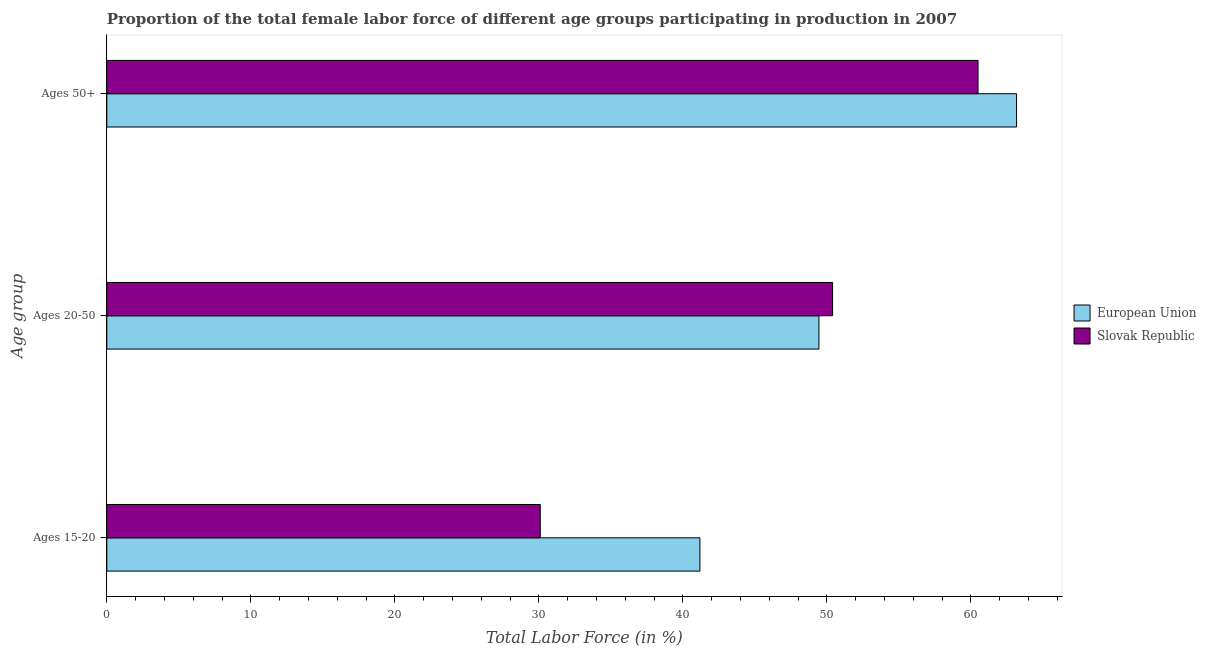Are the number of bars on each tick of the Y-axis equal?
Give a very brief answer. Yes. How many bars are there on the 2nd tick from the top?
Offer a very short reply. 2. What is the label of the 1st group of bars from the top?
Offer a terse response. Ages 50+. What is the percentage of female labor force above age 50 in Slovak Republic?
Keep it short and to the point. 60.5. Across all countries, what is the maximum percentage of female labor force within the age group 20-50?
Give a very brief answer. 50.4. Across all countries, what is the minimum percentage of female labor force above age 50?
Offer a terse response. 60.5. In which country was the percentage of female labor force within the age group 20-50 maximum?
Provide a succinct answer. Slovak Republic. In which country was the percentage of female labor force within the age group 15-20 minimum?
Keep it short and to the point. Slovak Republic. What is the total percentage of female labor force above age 50 in the graph?
Give a very brief answer. 123.67. What is the difference between the percentage of female labor force above age 50 in Slovak Republic and that in European Union?
Provide a short and direct response. -2.67. What is the difference between the percentage of female labor force within the age group 15-20 in European Union and the percentage of female labor force within the age group 20-50 in Slovak Republic?
Offer a terse response. -9.21. What is the average percentage of female labor force above age 50 per country?
Make the answer very short. 61.84. What is the difference between the percentage of female labor force above age 50 and percentage of female labor force within the age group 15-20 in European Union?
Provide a succinct answer. 21.99. What is the ratio of the percentage of female labor force above age 50 in European Union to that in Slovak Republic?
Make the answer very short. 1.04. Is the percentage of female labor force within the age group 15-20 in Slovak Republic less than that in European Union?
Your answer should be compact. Yes. Is the difference between the percentage of female labor force within the age group 20-50 in Slovak Republic and European Union greater than the difference between the percentage of female labor force above age 50 in Slovak Republic and European Union?
Ensure brevity in your answer.  Yes. What is the difference between the highest and the second highest percentage of female labor force within the age group 20-50?
Provide a succinct answer. 0.95. What is the difference between the highest and the lowest percentage of female labor force within the age group 15-20?
Your answer should be compact. 11.09. Is the sum of the percentage of female labor force within the age group 15-20 in Slovak Republic and European Union greater than the maximum percentage of female labor force above age 50 across all countries?
Give a very brief answer. Yes. Is it the case that in every country, the sum of the percentage of female labor force within the age group 15-20 and percentage of female labor force within the age group 20-50 is greater than the percentage of female labor force above age 50?
Keep it short and to the point. Yes. How many bars are there?
Your response must be concise. 6. Are all the bars in the graph horizontal?
Your answer should be very brief. Yes. How many countries are there in the graph?
Your answer should be compact. 2. What is the difference between two consecutive major ticks on the X-axis?
Your answer should be very brief. 10. Does the graph contain any zero values?
Give a very brief answer. No. Where does the legend appear in the graph?
Keep it short and to the point. Center right. How many legend labels are there?
Your response must be concise. 2. What is the title of the graph?
Make the answer very short. Proportion of the total female labor force of different age groups participating in production in 2007. Does "Arab World" appear as one of the legend labels in the graph?
Provide a succinct answer. No. What is the label or title of the X-axis?
Offer a very short reply. Total Labor Force (in %). What is the label or title of the Y-axis?
Offer a terse response. Age group. What is the Total Labor Force (in %) of European Union in Ages 15-20?
Your answer should be very brief. 41.19. What is the Total Labor Force (in %) of Slovak Republic in Ages 15-20?
Offer a terse response. 30.1. What is the Total Labor Force (in %) in European Union in Ages 20-50?
Your response must be concise. 49.45. What is the Total Labor Force (in %) of Slovak Republic in Ages 20-50?
Your answer should be very brief. 50.4. What is the Total Labor Force (in %) in European Union in Ages 50+?
Provide a succinct answer. 63.17. What is the Total Labor Force (in %) in Slovak Republic in Ages 50+?
Your answer should be very brief. 60.5. Across all Age group, what is the maximum Total Labor Force (in %) of European Union?
Your response must be concise. 63.17. Across all Age group, what is the maximum Total Labor Force (in %) of Slovak Republic?
Offer a terse response. 60.5. Across all Age group, what is the minimum Total Labor Force (in %) of European Union?
Make the answer very short. 41.19. Across all Age group, what is the minimum Total Labor Force (in %) of Slovak Republic?
Provide a succinct answer. 30.1. What is the total Total Labor Force (in %) in European Union in the graph?
Provide a succinct answer. 153.81. What is the total Total Labor Force (in %) of Slovak Republic in the graph?
Make the answer very short. 141. What is the difference between the Total Labor Force (in %) in European Union in Ages 15-20 and that in Ages 20-50?
Offer a very short reply. -8.26. What is the difference between the Total Labor Force (in %) in Slovak Republic in Ages 15-20 and that in Ages 20-50?
Your response must be concise. -20.3. What is the difference between the Total Labor Force (in %) of European Union in Ages 15-20 and that in Ages 50+?
Offer a very short reply. -21.99. What is the difference between the Total Labor Force (in %) of Slovak Republic in Ages 15-20 and that in Ages 50+?
Keep it short and to the point. -30.4. What is the difference between the Total Labor Force (in %) in European Union in Ages 20-50 and that in Ages 50+?
Keep it short and to the point. -13.72. What is the difference between the Total Labor Force (in %) in Slovak Republic in Ages 20-50 and that in Ages 50+?
Offer a very short reply. -10.1. What is the difference between the Total Labor Force (in %) in European Union in Ages 15-20 and the Total Labor Force (in %) in Slovak Republic in Ages 20-50?
Give a very brief answer. -9.21. What is the difference between the Total Labor Force (in %) in European Union in Ages 15-20 and the Total Labor Force (in %) in Slovak Republic in Ages 50+?
Make the answer very short. -19.31. What is the difference between the Total Labor Force (in %) of European Union in Ages 20-50 and the Total Labor Force (in %) of Slovak Republic in Ages 50+?
Ensure brevity in your answer.  -11.05. What is the average Total Labor Force (in %) of European Union per Age group?
Keep it short and to the point. 51.27. What is the average Total Labor Force (in %) of Slovak Republic per Age group?
Your answer should be very brief. 47. What is the difference between the Total Labor Force (in %) in European Union and Total Labor Force (in %) in Slovak Republic in Ages 15-20?
Offer a very short reply. 11.09. What is the difference between the Total Labor Force (in %) in European Union and Total Labor Force (in %) in Slovak Republic in Ages 20-50?
Offer a terse response. -0.95. What is the difference between the Total Labor Force (in %) in European Union and Total Labor Force (in %) in Slovak Republic in Ages 50+?
Give a very brief answer. 2.67. What is the ratio of the Total Labor Force (in %) in European Union in Ages 15-20 to that in Ages 20-50?
Provide a succinct answer. 0.83. What is the ratio of the Total Labor Force (in %) of Slovak Republic in Ages 15-20 to that in Ages 20-50?
Offer a terse response. 0.6. What is the ratio of the Total Labor Force (in %) of European Union in Ages 15-20 to that in Ages 50+?
Give a very brief answer. 0.65. What is the ratio of the Total Labor Force (in %) of Slovak Republic in Ages 15-20 to that in Ages 50+?
Offer a very short reply. 0.5. What is the ratio of the Total Labor Force (in %) in European Union in Ages 20-50 to that in Ages 50+?
Offer a terse response. 0.78. What is the ratio of the Total Labor Force (in %) of Slovak Republic in Ages 20-50 to that in Ages 50+?
Make the answer very short. 0.83. What is the difference between the highest and the second highest Total Labor Force (in %) of European Union?
Provide a succinct answer. 13.72. What is the difference between the highest and the lowest Total Labor Force (in %) of European Union?
Offer a very short reply. 21.99. What is the difference between the highest and the lowest Total Labor Force (in %) of Slovak Republic?
Keep it short and to the point. 30.4. 